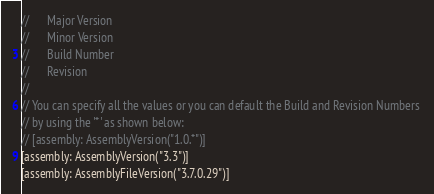Convert code to text. <code><loc_0><loc_0><loc_500><loc_500><_C#_>//      Major Version
//      Minor Version 
//      Build Number
//      Revision
//
// You can specify all the values or you can default the Build and Revision Numbers 
// by using the '*' as shown below:
// [assembly: AssemblyVersion("1.0.*")]
[assembly: AssemblyVersion("3.3")]
[assembly: AssemblyFileVersion("3.7.0.29")]</code> 